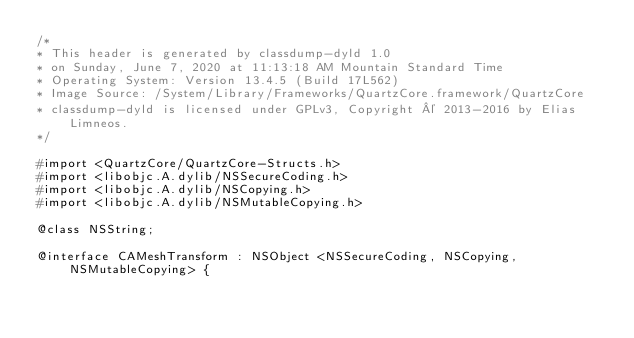<code> <loc_0><loc_0><loc_500><loc_500><_C_>/*
* This header is generated by classdump-dyld 1.0
* on Sunday, June 7, 2020 at 11:13:18 AM Mountain Standard Time
* Operating System: Version 13.4.5 (Build 17L562)
* Image Source: /System/Library/Frameworks/QuartzCore.framework/QuartzCore
* classdump-dyld is licensed under GPLv3, Copyright © 2013-2016 by Elias Limneos.
*/

#import <QuartzCore/QuartzCore-Structs.h>
#import <libobjc.A.dylib/NSSecureCoding.h>
#import <libobjc.A.dylib/NSCopying.h>
#import <libobjc.A.dylib/NSMutableCopying.h>

@class NSString;

@interface CAMeshTransform : NSObject <NSSecureCoding, NSCopying, NSMutableCopying> {
</code> 